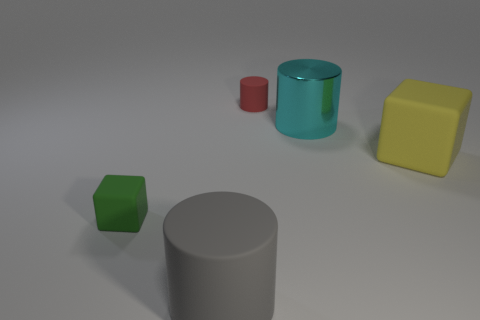Add 3 small green cubes. How many objects exist? 8 Subtract all blocks. How many objects are left? 3 Subtract all small yellow matte cubes. Subtract all metal things. How many objects are left? 4 Add 3 big rubber blocks. How many big rubber blocks are left? 4 Add 5 shiny objects. How many shiny objects exist? 6 Subtract 0 purple balls. How many objects are left? 5 